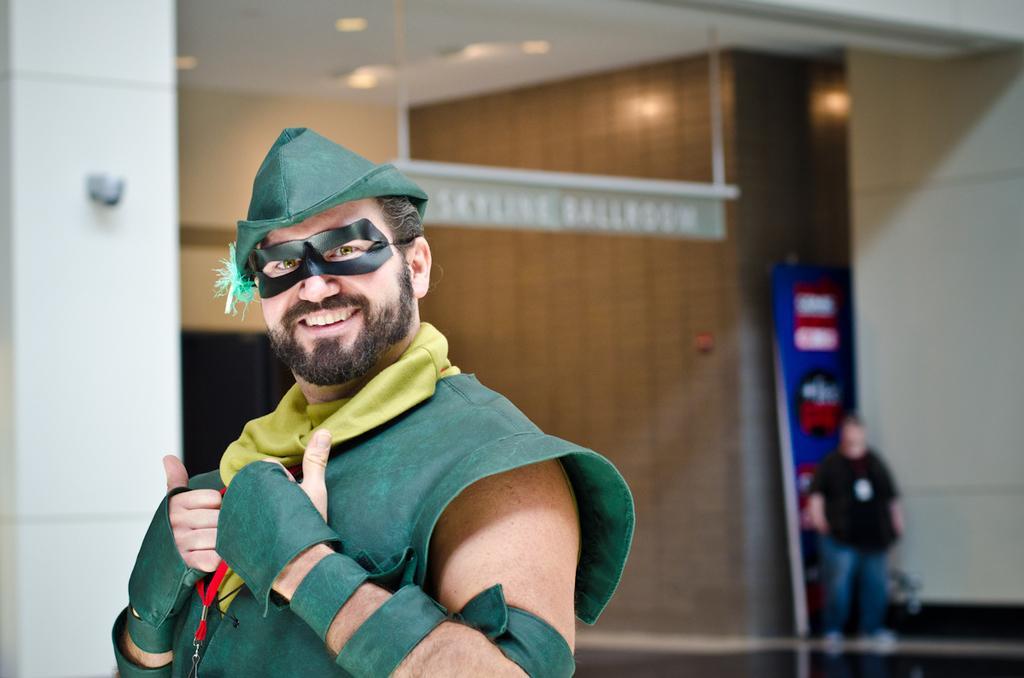Could you give a brief overview of what you see in this image? In this image I can see a person standing who is wearing drama costume, behind him there is a building and another person. 